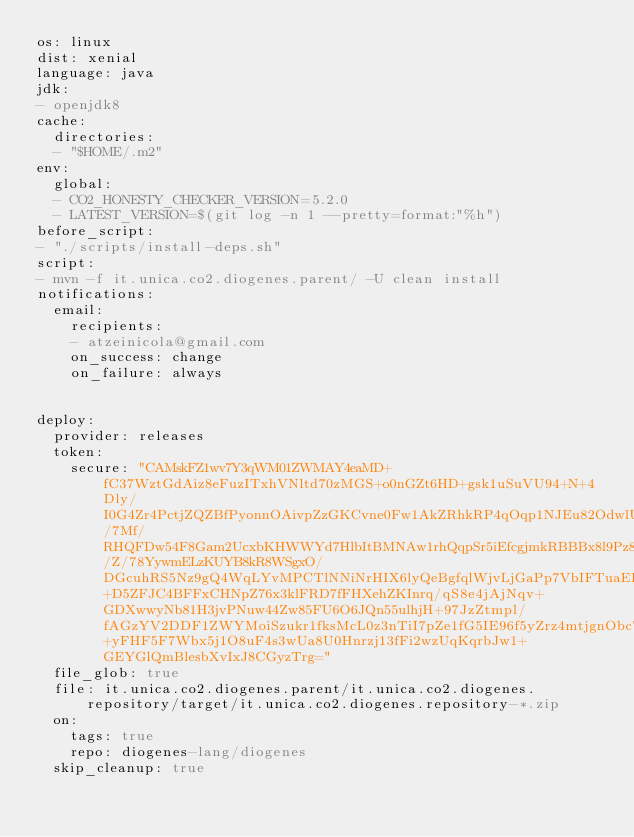Convert code to text. <code><loc_0><loc_0><loc_500><loc_500><_YAML_>os: linux
dist: xenial
language: java
jdk:
- openjdk8
cache:
  directories:
  - "$HOME/.m2"
env:
  global:
  - CO2_HONESTY_CHECKER_VERSION=5.2.0
  - LATEST_VERSION=$(git log -n 1 --pretty=format:"%h")
before_script:
- "./scripts/install-deps.sh"
script:
- mvn -f it.unica.co2.diogenes.parent/ -U clean install
notifications:
  email:
    recipients:
    - atzeinicola@gmail.com
    on_success: change
    on_failure: always


deploy:
  provider: releases
  token:
    secure: "CAMskFZ1wv7Y3qWM01ZWMAY4eaMD+fC37WztGdAiz8eFuzITxhVNltd70zMGS+o0nGZt6HD+gsk1uSuVU94+N+4Dly/I0G4Zr4PctjZQZBfPyonnOAivpZzGKCvne0Fw1AkZRhkRP4qOqp1NJEu82OdwlUhDoujrcZbBCO1RcJBvFw27qjuKoLKDB00i80B03S09gHX3cqi5Z4GJzMaFN/7Mf/RHQFDw54F8Gam2UcxbKHWWYd7HlbItBMNAw1rhQqpSr5iEfcgjmkRBBBx8l9Pz8A1/Z/78YywmELzKUYB8kR8WSgxO/DGcuhRS5Nz9gQ4WqLYvMPCTlNNiNrHIX6lyQeBgfqlWjvLjGaPp7VbIFTuaEErcnvc1VUpkaifPfI55kTdVQpDT8qton5IosccQydVwk6Eteho0iGWFLIDawllBqlsmZ+D5ZFJC4BFFxCHNpZ76x3klFRD7fFHXehZKInrq/qS8e4jAjNqv+GDXwwyNb81H3jvPNuw44Zw85FU6O6JQn55ulhjH+97JzZtmpl/fAGzYV2DDF1ZWYMoiSzukr1fksMcL0z3nTiI7pZe1fG5IE96f5yZrz4mtjgnObcT3ImEa+yFHF5F7Wbx5j1O8uF4s3wUa8U0Hnrzj13fFi2wzUqKqrbJw1+GEYGlQmBlesbXvIxJ8CGyzTrg="
  file_glob: true
  file: it.unica.co2.diogenes.parent/it.unica.co2.diogenes.repository/target/it.unica.co2.diogenes.repository-*.zip
  on:
    tags: true
    repo: diogenes-lang/diogenes
  skip_cleanup: true
</code> 